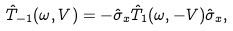Convert formula to latex. <formula><loc_0><loc_0><loc_500><loc_500>\hat { T } _ { - 1 } ( \omega , V ) = - \hat { \sigma } _ { x } \hat { T } _ { 1 } ( \omega , - V ) \hat { \sigma } _ { x } ,</formula> 